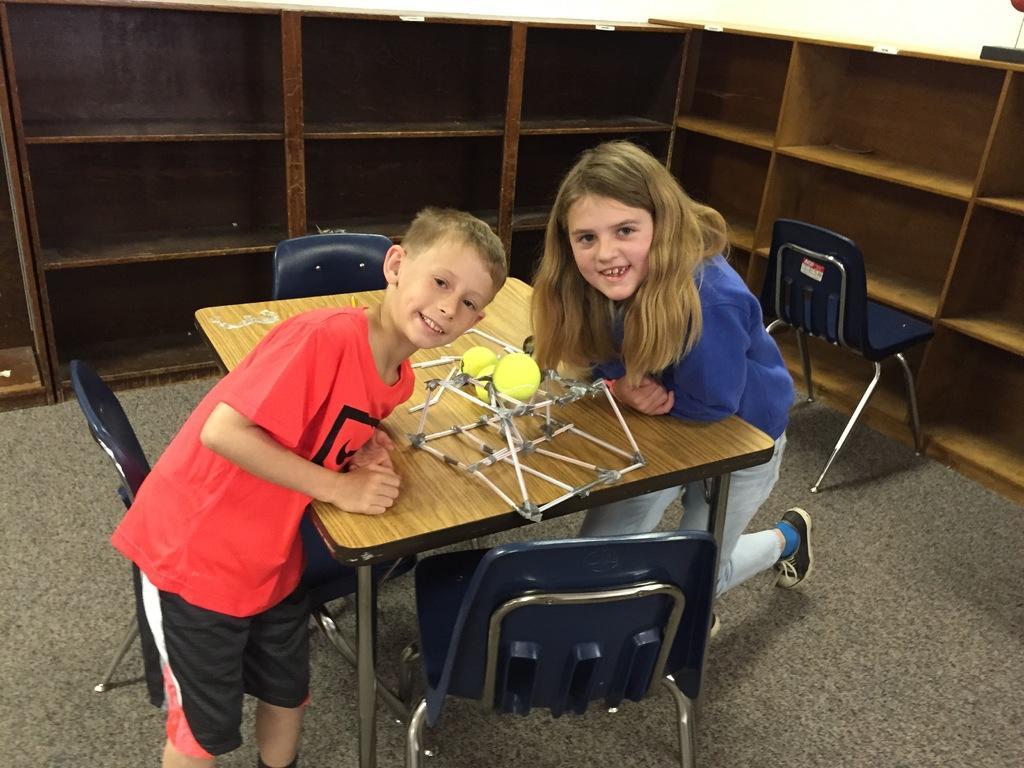Can you describe this image briefly? This image is clicked inside the room. There are two persons in this image. In the middle there is a table on which toy is kept. To the left, the boy is wearing red t-shirt. To the right, the girl is wearing blue t-shirt. In the background, there are wooden racks. 